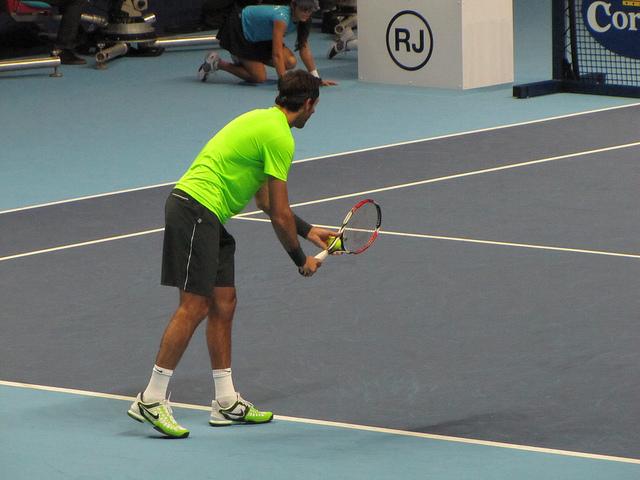What color stands out?
Give a very brief answer. Green. What brand of clothing is the man wearing?
Keep it brief. Nike. What job does that girl near the net have to do?
Concise answer only. Get ball. What sport is being played?
Be succinct. Tennis. 